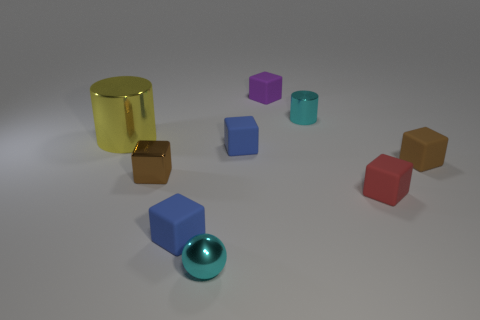Is the number of small cyan metallic cylinders on the left side of the yellow object greater than the number of spheres?
Offer a terse response. No. Is the shape of the cyan thing that is behind the yellow cylinder the same as  the large object?
Offer a terse response. Yes. What number of yellow objects are small metal cubes or rubber blocks?
Make the answer very short. 0. Is the number of metal objects greater than the number of cyan things?
Ensure brevity in your answer.  Yes. What is the color of the ball that is the same size as the metallic block?
Your response must be concise. Cyan. How many cubes are tiny blue rubber things or cyan metal objects?
Give a very brief answer. 2. There is a large yellow shiny thing; is it the same shape as the brown thing to the left of the brown rubber block?
Your answer should be compact. No. What number of brown metal objects are the same size as the red object?
Keep it short and to the point. 1. There is a cyan metallic object on the left side of the purple rubber cube; is its shape the same as the cyan object that is on the right side of the tiny metallic sphere?
Offer a terse response. No. There is a object that is the same color as the shiny cube; what shape is it?
Your answer should be compact. Cube. 